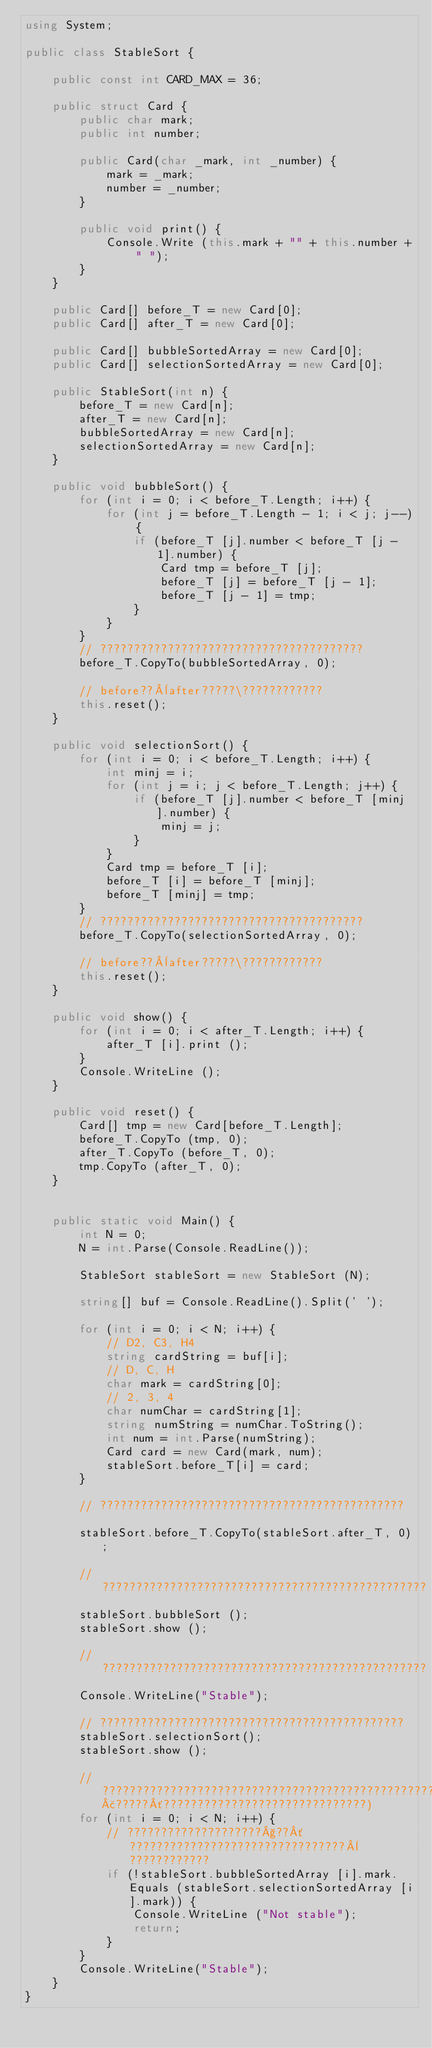<code> <loc_0><loc_0><loc_500><loc_500><_C#_>using System;

public class StableSort {

    public const int CARD_MAX = 36;
       
    public struct Card {
		public char mark;
		public int number;

		public Card(char _mark, int _number) {
		    mark = _mark;
	    	number = _number;
		}

		public void print() {
			Console.Write (this.mark + "" + this.number + " ");
		}
    }

	public Card[] before_T = new Card[0];
	public Card[] after_T = new Card[0];

	public Card[] bubbleSortedArray = new Card[0];
	public Card[] selectionSortedArray = new Card[0];

	public StableSort(int n) {
		before_T = new Card[n];
		after_T = new Card[n];
		bubbleSortedArray = new Card[n];
		selectionSortedArray = new Card[n];
	}

	public void bubbleSort() {
		for (int i = 0; i < before_T.Length; i++) {
			for (int j = before_T.Length - 1; i < j; j--) {
				if (before_T [j].number < before_T [j - 1].number) {
					Card tmp = before_T [j];
					before_T [j] = before_T [j - 1];
					before_T [j - 1] = tmp;
				}
			}
		}
		// ???????????????????????????????????????
		before_T.CopyTo(bubbleSortedArray, 0);

		// before??¨after?????\????????????
		this.reset();
	}

	public void selectionSort() {
		for (int i = 0; i < before_T.Length; i++) {
			int minj = i;
			for (int j = i; j < before_T.Length; j++) {
				if (before_T [j].number < before_T [minj].number) {
					minj = j;
				}
			}
			Card tmp = before_T [i];
			before_T [i] = before_T [minj];
			before_T [minj] = tmp;
		}
		// ???????????????????????????????????????
		before_T.CopyTo(selectionSortedArray, 0);

		// before??¨after?????\????????????
		this.reset();
	}

	public void show() {
		for (int i = 0; i < after_T.Length; i++) {
			after_T [i].print ();			
		}
		Console.WriteLine ();
	}

	public void reset() {
		Card[] tmp = new Card[before_T.Length];
		before_T.CopyTo (tmp, 0);
		after_T.CopyTo (before_T, 0);
		tmp.CopyTo (after_T, 0);
	}
		
    
    public static void Main() {		
		int N = 0;
		N = int.Parse(Console.ReadLine());

		StableSort stableSort = new StableSort (N);

		string[] buf = Console.ReadLine().Split(' ');
			
		for (int i = 0; i < N; i++) {
		    // D2, C3, H4
	    	string cardString = buf[i];			
	    	// D, C, H
			char mark = cardString[0];
	    	// 2, 3, 4
			char numChar = cardString[1];			
			string numString = numChar.ToString();
			int num = int.Parse(numString);
	    	Card card = new Card(mark, num);
			stableSort.before_T[i] = card;			
		}

		// ?????????????????????????????????????????????				
		stableSort.before_T.CopyTo(stableSort.after_T, 0);

		// ????????????????????????????????????????????????
		stableSort.bubbleSort ();
		stableSort.show ();

		// ????????????????????????????????????????????????
		Console.WriteLine("Stable");

		// ?????????????????????????????????????????????
		stableSort.selectionSort();
		stableSort.show ();

		// ?????????????????????????????????????????????????????????(??????????????????????????£?????´??????????????????????????????)		
		for (int i = 0; i < N; i++) {
			// ????????????????????§??´????????????????????????????????¨????????????
			if (!stableSort.bubbleSortedArray [i].mark.Equals (stableSort.selectionSortedArray [i].mark)) {
				Console.WriteLine ("Not stable");
				return;
			}
		}
		Console.WriteLine("Stable");
    }
}</code> 